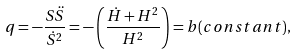Convert formula to latex. <formula><loc_0><loc_0><loc_500><loc_500>q = - \frac { S \ddot { S } } { { \dot { S } } ^ { 2 } } = - \left ( \frac { \dot { H } + H ^ { 2 } } { H ^ { 2 } } \right ) = b ( c o n s t a n t ) ,</formula> 